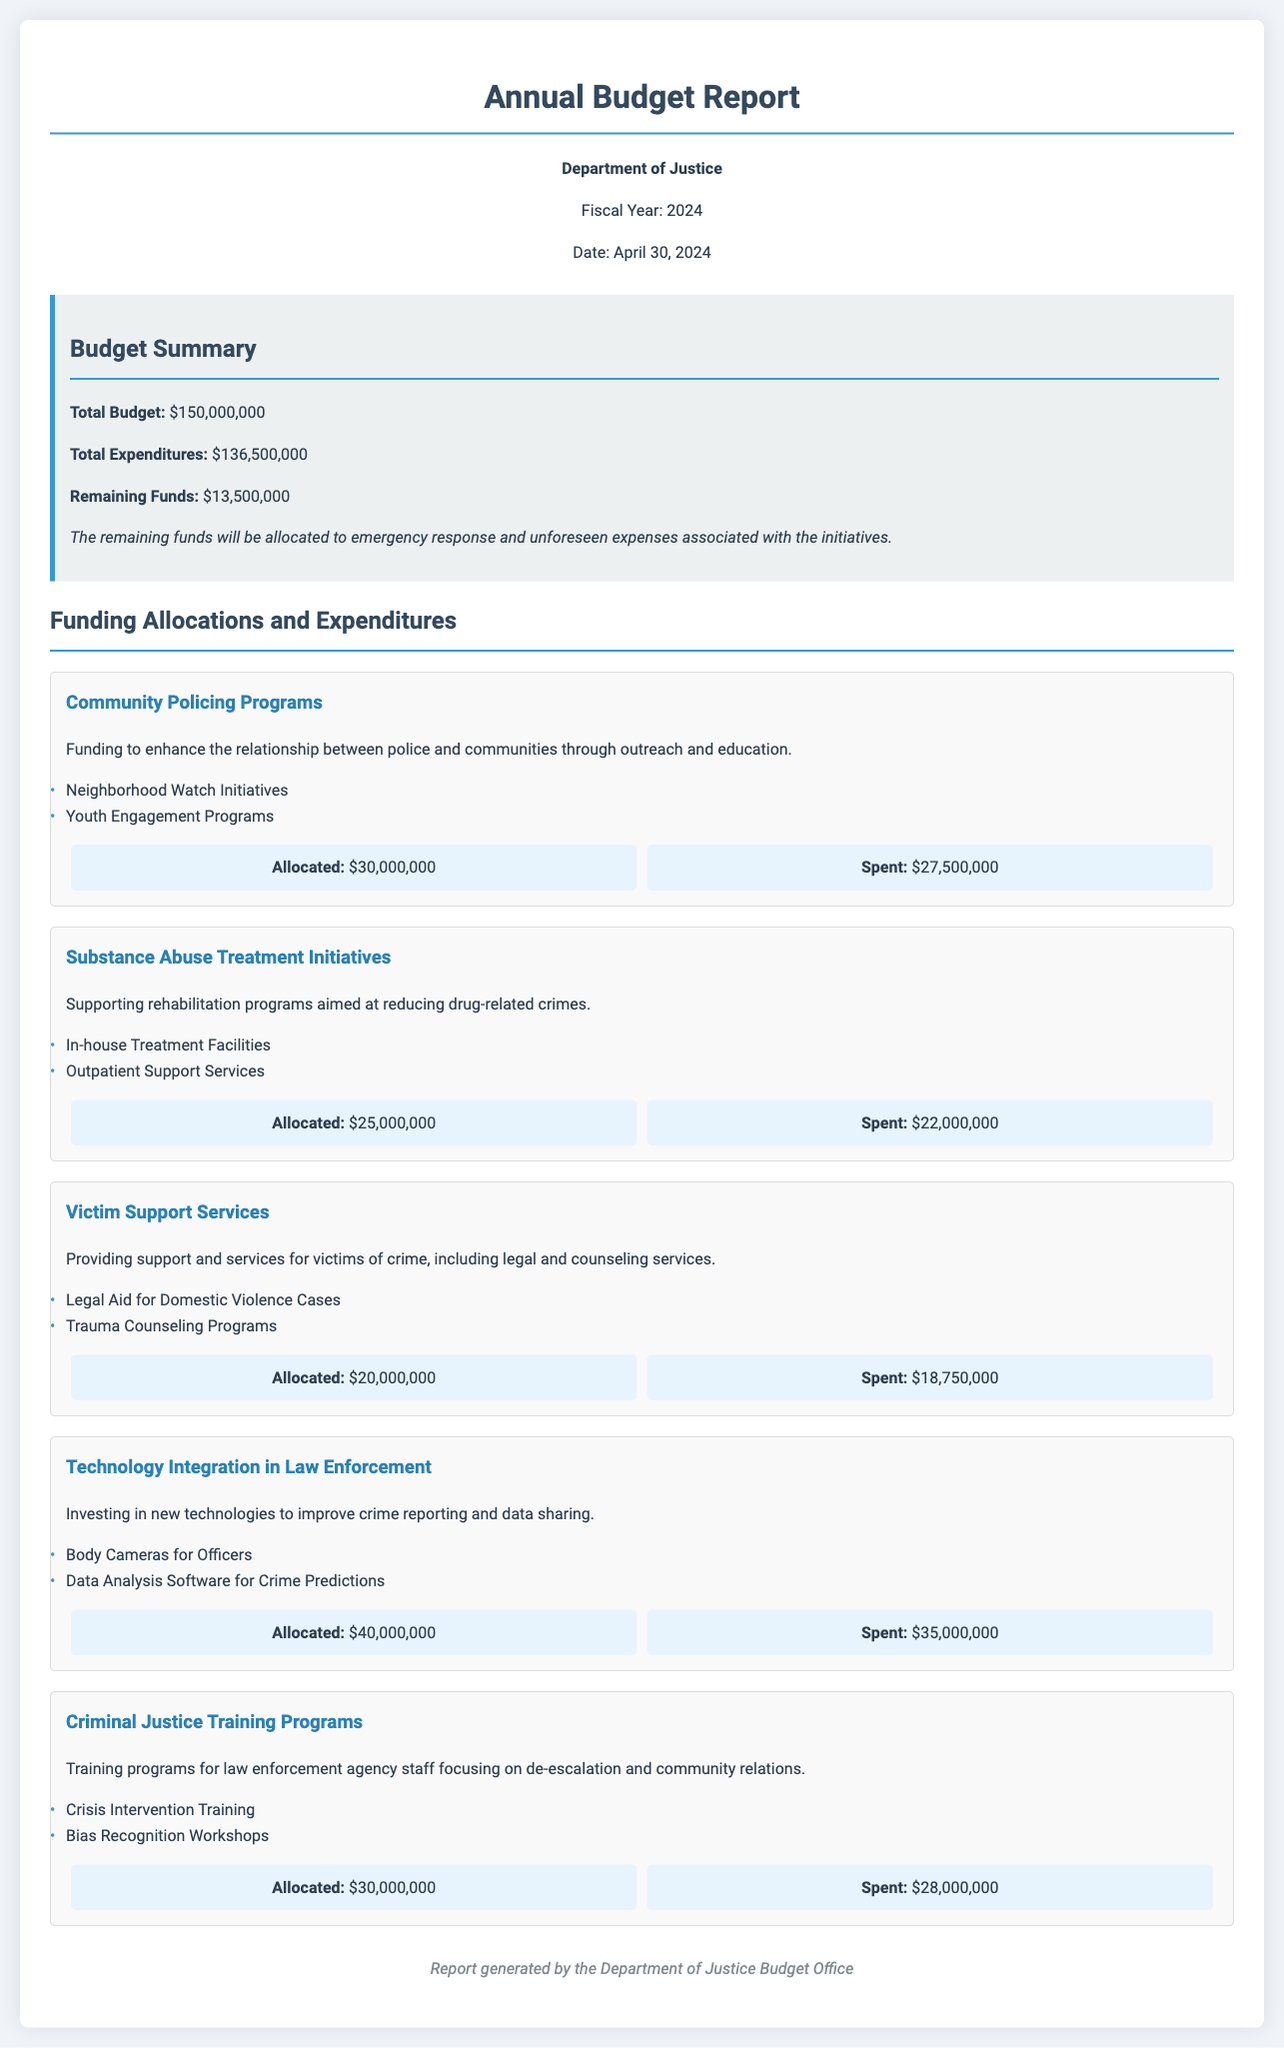What is the total budget? The total budget is stated clearly in the document under the Budget Summary section.
Answer: $150,000,000 What is the total expenditure? The total expenditure is provided in the Budget Summary section of the document.
Answer: $136,500,000 How much funding is allocated to Community Policing Programs? The amount allocated to Community Policing Programs is specifically given in the Funding Allocations and Expenditures section.
Answer: $30,000,000 What remains in the budget for emergency response? The remaining funds section reveals the amount left for emergency response and unforeseen expenses.
Answer: $13,500,000 Which initiative received the highest funding allocation? By comparing the allocations, we can identify the initiative with the highest funding.
Answer: Technology Integration in Law Enforcement How much was spent on Substance Abuse Treatment Initiatives? This information is found in the budget info section for the Substance Abuse Treatment Initiatives.
Answer: $22,000,000 What key project is included in Victim Support Services? The document lists several key projects for each initiative, including those under Victim Support Services.
Answer: Legal Aid for Domestic Violence Cases What training topic is covered in Criminal Justice Training Programs? The document mentions specific topics related to training programs in law enforcement.
Answer: Crisis Intervention Training What is the date of the report? The date of the report is stated in the header section.
Answer: April 30, 2024 